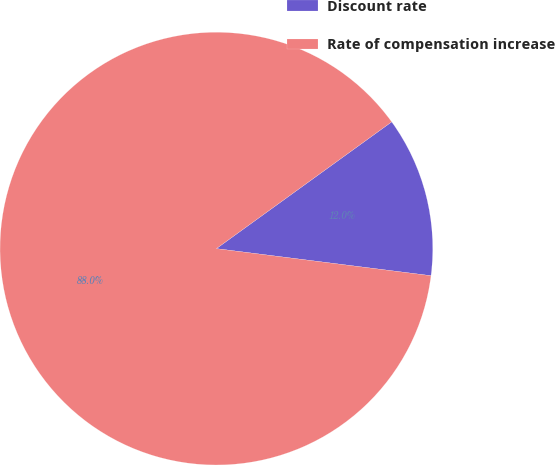<chart> <loc_0><loc_0><loc_500><loc_500><pie_chart><fcel>Discount rate<fcel>Rate of compensation increase<nl><fcel>11.96%<fcel>88.04%<nl></chart> 